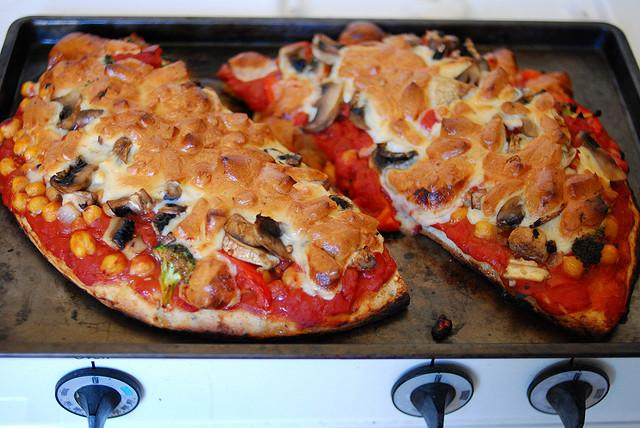What are the round things on the outer edge? chickpeas 